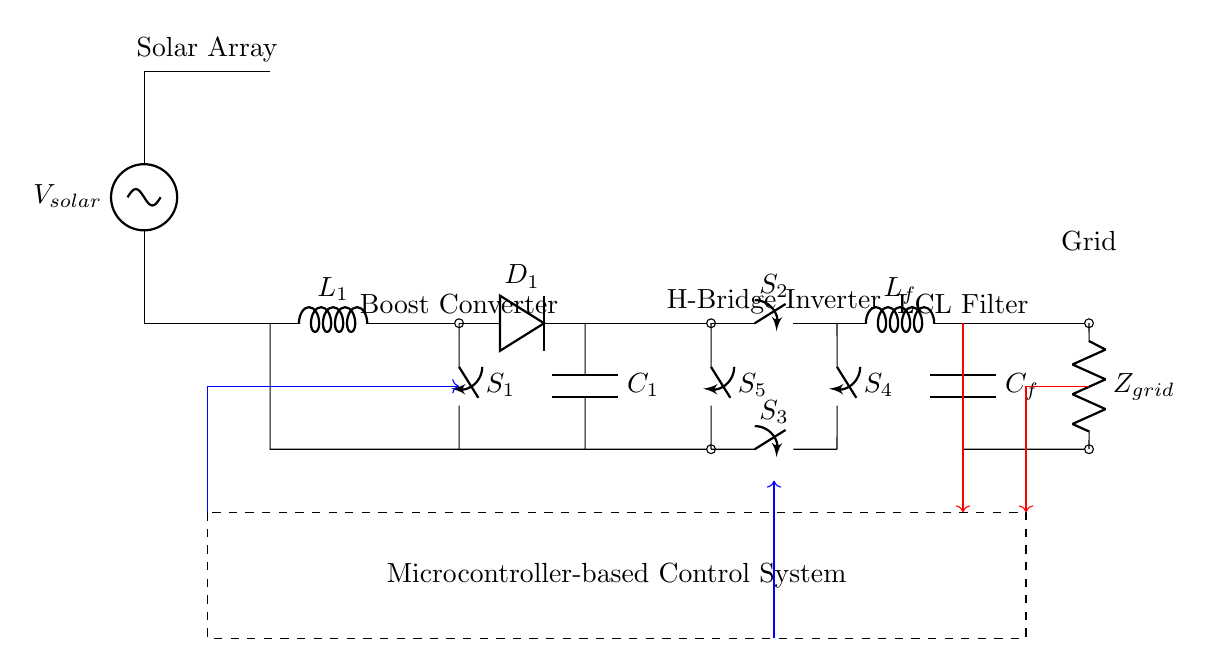What is the main function of the boost converter in this circuit? The boost converter increases the voltage from the solar array to a higher level suitable for the inverter while improving system efficiency.
Answer: Increase voltage What type of control system is indicated in the circuit? The circuit has a microcontroller-based control system that manages the operation of the inverter and ensures stability and efficiency in energy conversion.
Answer: Microcontroller-based How many switches are present in the inverter section? There are four switches labeled S2, S3, S4, and S5 in the H-bridge inverter configuration used for controlling the flow of electricity.
Answer: Four What is the role of the LCL filter? The LCL filter smooths the output current and voltage to reduce harmonic distortion before connecting to the grid, ensuring compliance with grid standards.
Answer: Smooth output What type of energy source is used in this circuit? The source is a solar array, as indicated by the voltage source labeled V_solar, which generates electricity from solar energy.
Answer: Solar energy What is the purpose of the feedback lines in the circuit? The feedback lines provide information to the control system about the output current and voltage, allowing for real-time adjustments to maintain optimal performance and efficiency.
Answer: Real-time adjustments 